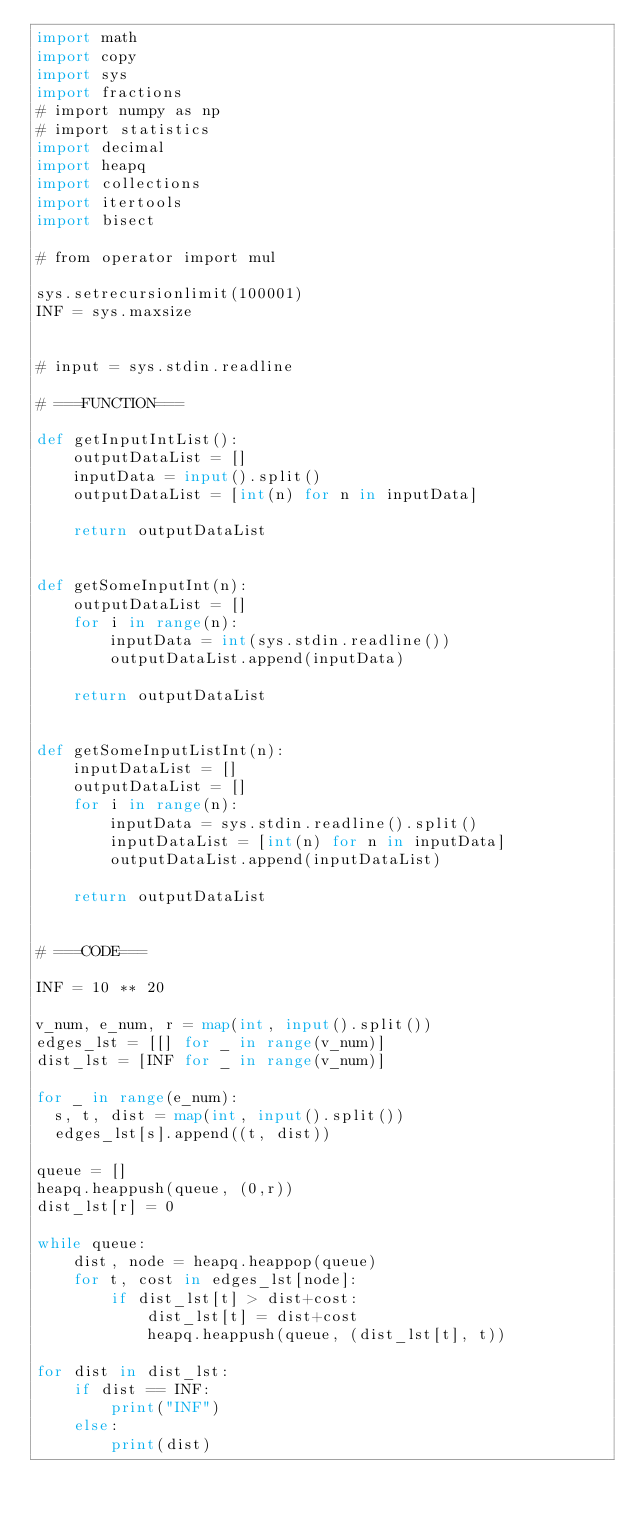<code> <loc_0><loc_0><loc_500><loc_500><_Python_>import math
import copy
import sys
import fractions
# import numpy as np
# import statistics
import decimal
import heapq
import collections
import itertools
import bisect

# from operator import mul

sys.setrecursionlimit(100001)
INF = sys.maxsize


# input = sys.stdin.readline

# ===FUNCTION===

def getInputIntList():
    outputDataList = []
    inputData = input().split()
    outputDataList = [int(n) for n in inputData]

    return outputDataList


def getSomeInputInt(n):
    outputDataList = []
    for i in range(n):
        inputData = int(sys.stdin.readline())
        outputDataList.append(inputData)

    return outputDataList


def getSomeInputListInt(n):
    inputDataList = []
    outputDataList = []
    for i in range(n):
        inputData = sys.stdin.readline().split()
        inputDataList = [int(n) for n in inputData]
        outputDataList.append(inputDataList)

    return outputDataList


# ===CODE===

INF = 10 ** 20

v_num, e_num, r = map(int, input().split())
edges_lst = [[] for _ in range(v_num)]
dist_lst = [INF for _ in range(v_num)]

for _ in range(e_num):
  s, t, dist = map(int, input().split())
  edges_lst[s].append((t, dist))

queue = []
heapq.heappush(queue, (0,r))
dist_lst[r] = 0

while queue:
    dist, node = heapq.heappop(queue)
    for t, cost in edges_lst[node]:
        if dist_lst[t] > dist+cost:
            dist_lst[t] = dist+cost
            heapq.heappush(queue, (dist_lst[t], t))

for dist in dist_lst:
    if dist == INF:
        print("INF")
    else:
        print(dist)



</code> 